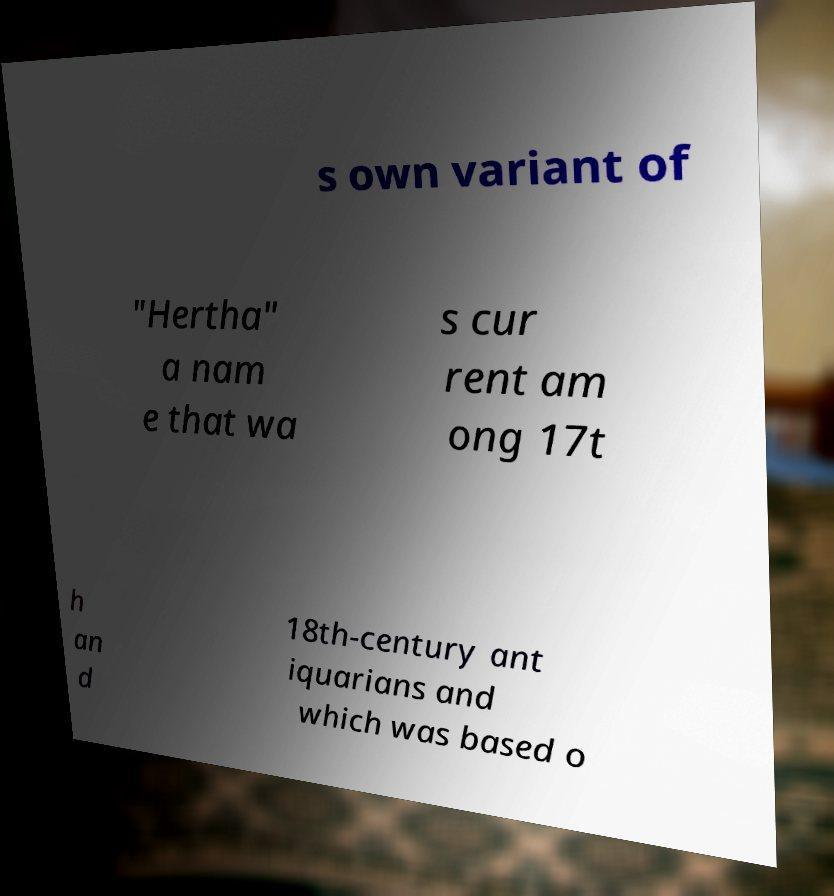Could you extract and type out the text from this image? s own variant of "Hertha" a nam e that wa s cur rent am ong 17t h an d 18th-century ant iquarians and which was based o 